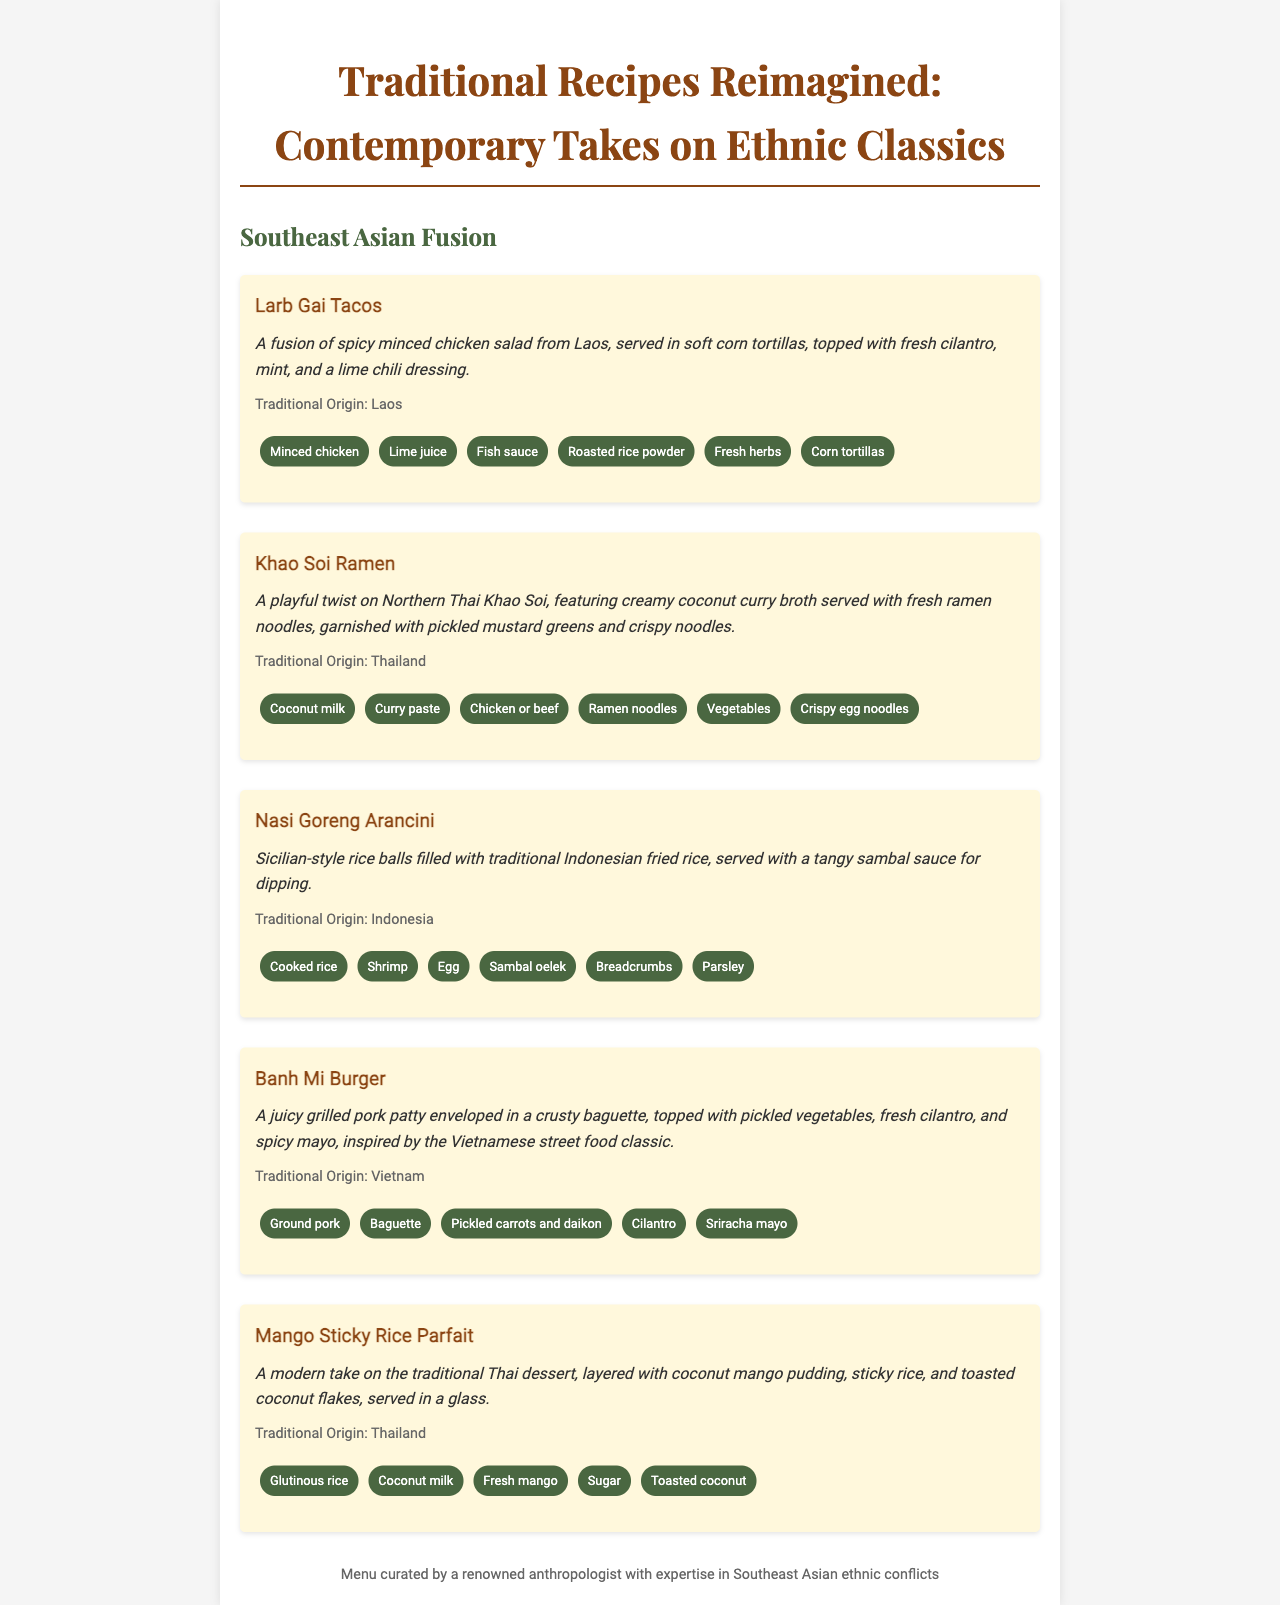What is the title of the menu? The title is prominently displayed at the top of the document, announcing the theme of the restaurant offerings.
Answer: Traditional Recipes Reimagined: Contemporary Takes on Ethnic Classics How many dishes are featured in the menu? The menu includes five distinct dishes that showcase a blend of traditional and contemporary flavors.
Answer: 5 What is the origin of Larb Gai Tacos? Each dish includes a section noting its traditional provenance, specifically for Larb Gai Tacos the origin is mentioned.
Answer: Laos Which dish features coconut milk as an ingredient? By examining the list of ingredients for each dish, one can determine which includes coconut milk.
Answer: Khao Soi Ramen What type of cuisine inspires the Banh Mi Burger? The description specifies the cultural background of the dish, linking it to a well-known traditional food item.
Answer: Vietnamese What is served with the Nasi Goreng Arancini for dipping? The menu entries detail accompaniments or sauces that come with the dishes, indicating this particular pairing.
Answer: Tangy sambal sauce Which dessert is listed on the menu? This identifies a specific category (dessert) present in the menu and highlights choices available.
Answer: Mango Sticky Rice Parfait What is the color scheme of the dish descriptions? The descriptions are formatted in a way that highlights the aesthetic choices made in presenting the dishes on the menu.
Answer: Italic 